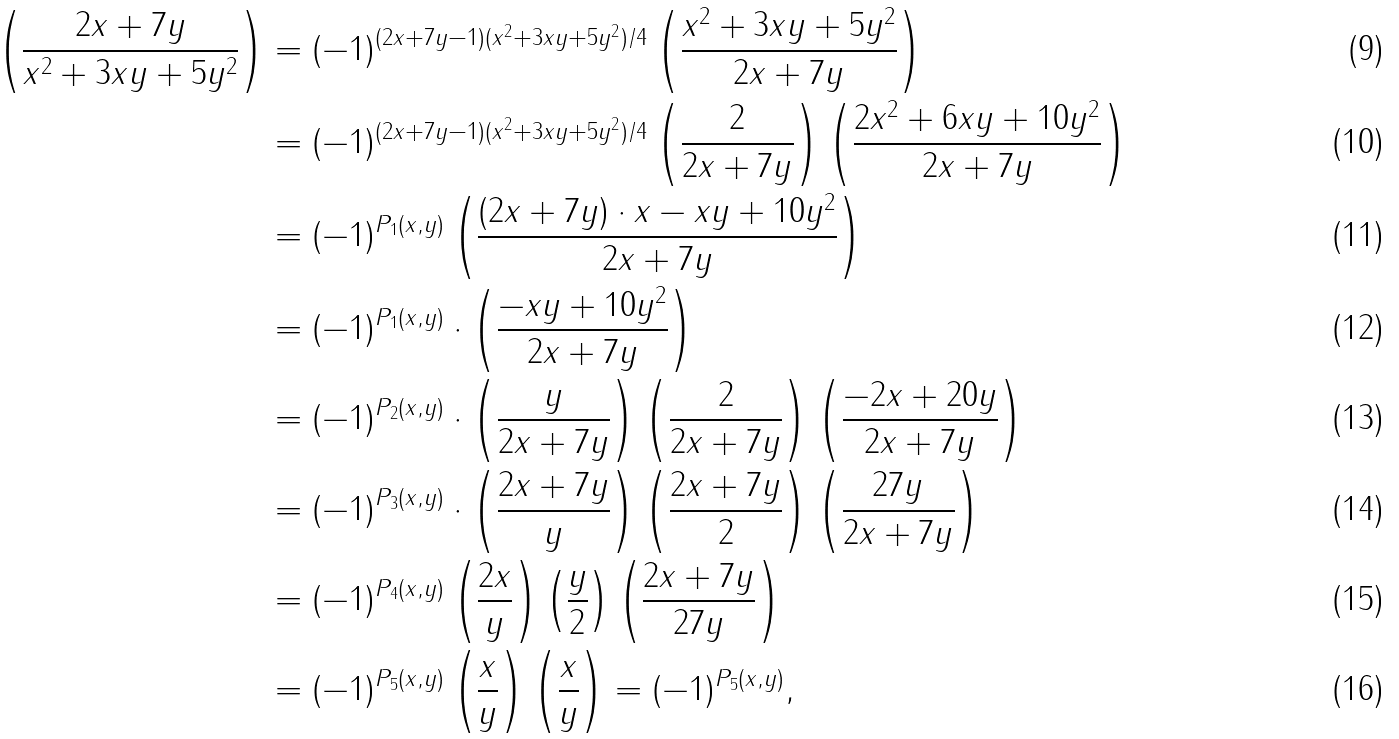Convert formula to latex. <formula><loc_0><loc_0><loc_500><loc_500>\left ( \frac { 2 x + 7 y } { x ^ { 2 } + 3 x y + 5 y ^ { 2 } } \right ) & = ( - 1 ) ^ { ( 2 x + 7 y - 1 ) ( x ^ { 2 } + 3 x y + 5 y ^ { 2 } ) / 4 } \left ( \frac { x ^ { 2 } + 3 x y + 5 y ^ { 2 } } { 2 x + 7 y } \right ) \\ & = ( - 1 ) ^ { ( 2 x + 7 y - 1 ) ( x ^ { 2 } + 3 x y + 5 y ^ { 2 } ) / 4 } \left ( \frac { 2 } { 2 x + 7 y } \right ) \left ( \frac { 2 x ^ { 2 } + 6 x y + 1 0 y ^ { 2 } } { 2 x + 7 y } \right ) \\ & = ( - 1 ) ^ { P _ { 1 } ( x , y ) } \left ( \frac { ( 2 x + 7 y ) \cdot x - x y + 1 0 y ^ { 2 } } { 2 x + 7 y } \right ) \\ & = ( - 1 ) ^ { P _ { 1 } ( x , y ) } \cdot \left ( \frac { - x y + 1 0 y ^ { 2 } } { 2 x + 7 y } \right ) \\ & = ( - 1 ) ^ { P _ { 2 } ( x , y ) } \cdot \left ( \frac { y } { 2 x + 7 y } \right ) \left ( \frac { 2 } { 2 x + 7 y } \right ) \left ( \frac { - 2 x + 2 0 y } { 2 x + 7 y } \right ) \\ & = ( - 1 ) ^ { P _ { 3 } ( x , y ) } \cdot \left ( \frac { 2 x + 7 y } { y } \right ) \left ( \frac { 2 x + 7 y } { 2 } \right ) \left ( \frac { 2 7 y } { 2 x + 7 y } \right ) \\ & = ( - 1 ) ^ { P _ { 4 } ( x , y ) } \left ( \frac { 2 x } { y } \right ) \left ( \frac { y } { 2 } \right ) \left ( \frac { 2 x + 7 y } { 2 7 y } \right ) \\ & = ( - 1 ) ^ { P _ { 5 } ( x , y ) } \left ( \frac { x } { y } \right ) \left ( \frac { x } { y } \right ) = ( - 1 ) ^ { P _ { 5 } ( x , y ) } ,</formula> 